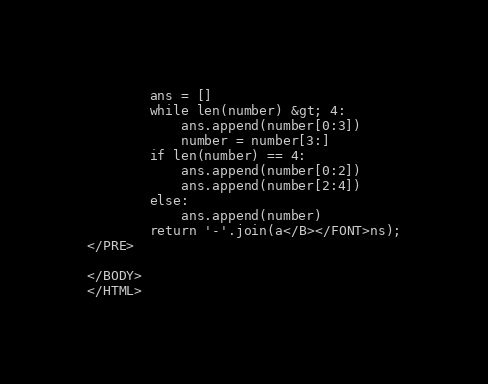Convert code to text. <code><loc_0><loc_0><loc_500><loc_500><_HTML_>        ans = []
        while len(number) &gt; 4:
            ans.append(number[0:3])
            number = number[3:]
        if len(number) == 4:
            ans.append(number[0:2])
            ans.append(number[2:4])
        else:
            ans.append(number)
        return '-'.join(a</B></FONT>ns);
</PRE>

</BODY>
</HTML>
</code> 